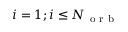<formula> <loc_0><loc_0><loc_500><loc_500>i = 1 ; i \leq N _ { o r b }</formula> 